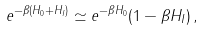<formula> <loc_0><loc_0><loc_500><loc_500>e ^ { - \beta ( H _ { 0 } + H _ { I } ) } \simeq e ^ { - \beta H _ { 0 } } ( 1 - \beta H _ { I } ) \, ,</formula> 